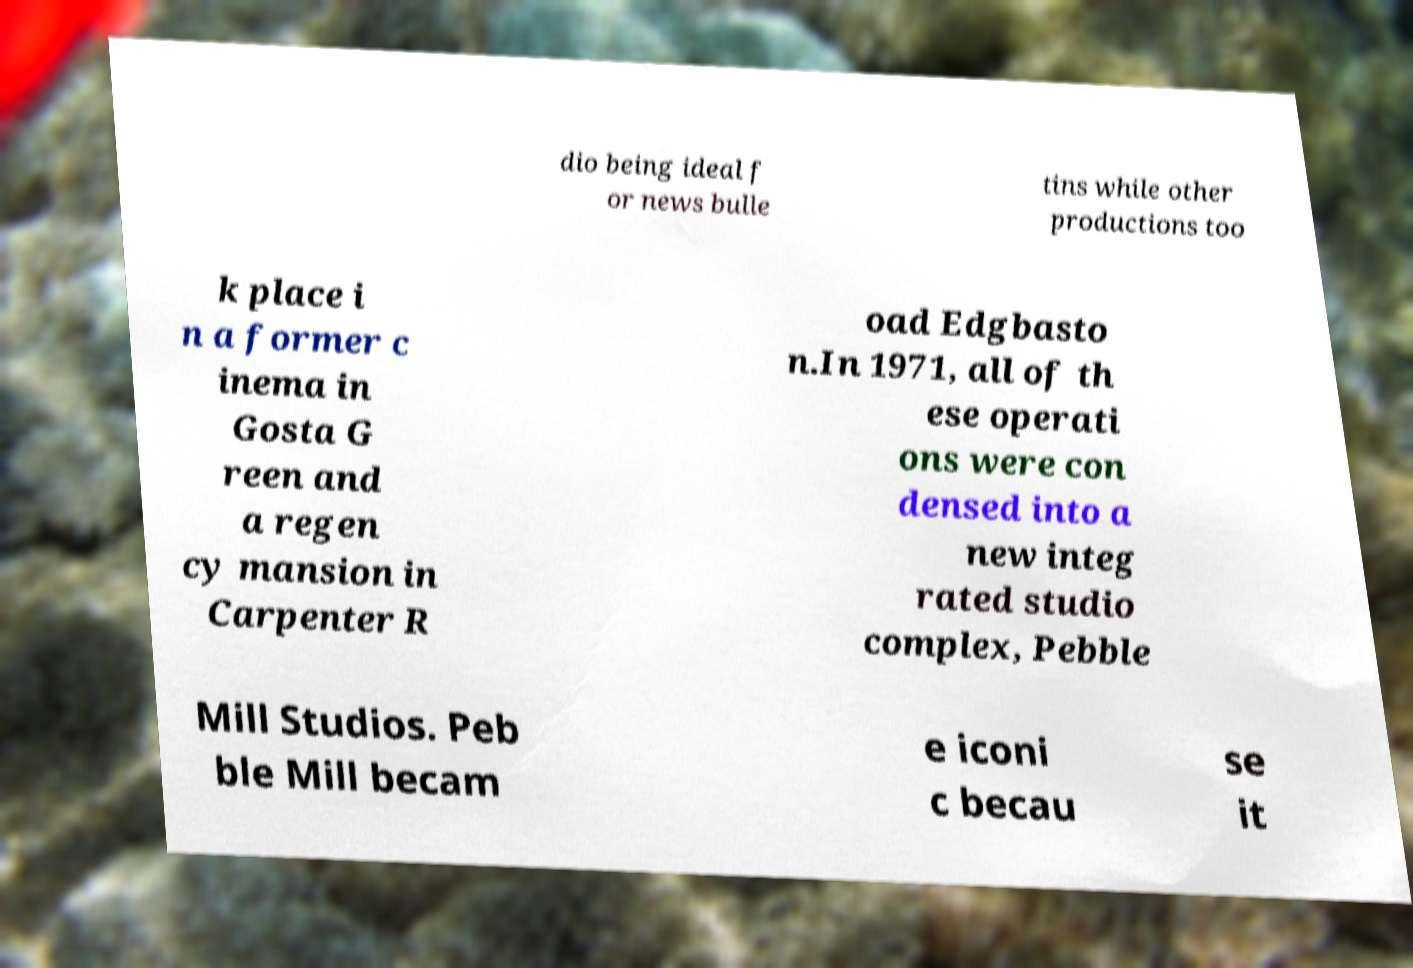Can you read and provide the text displayed in the image?This photo seems to have some interesting text. Can you extract and type it out for me? dio being ideal f or news bulle tins while other productions too k place i n a former c inema in Gosta G reen and a regen cy mansion in Carpenter R oad Edgbasto n.In 1971, all of th ese operati ons were con densed into a new integ rated studio complex, Pebble Mill Studios. Peb ble Mill becam e iconi c becau se it 